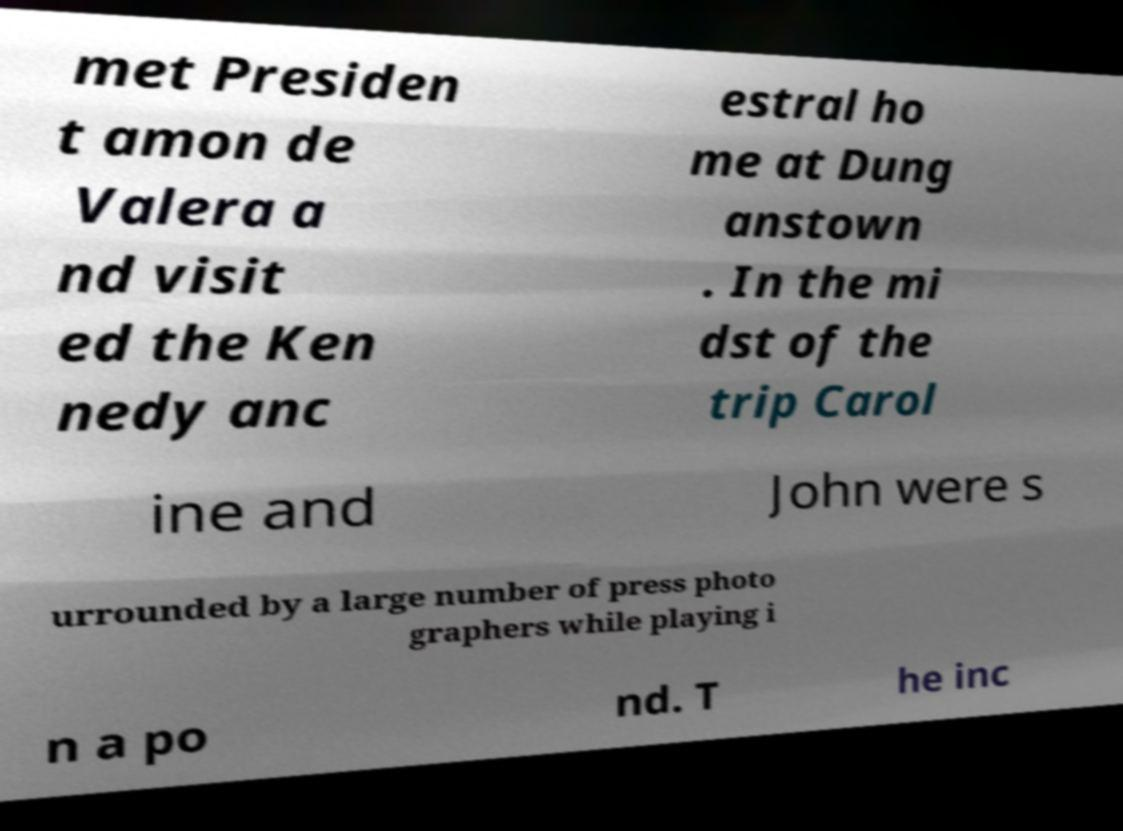Can you accurately transcribe the text from the provided image for me? met Presiden t amon de Valera a nd visit ed the Ken nedy anc estral ho me at Dung anstown . In the mi dst of the trip Carol ine and John were s urrounded by a large number of press photo graphers while playing i n a po nd. T he inc 